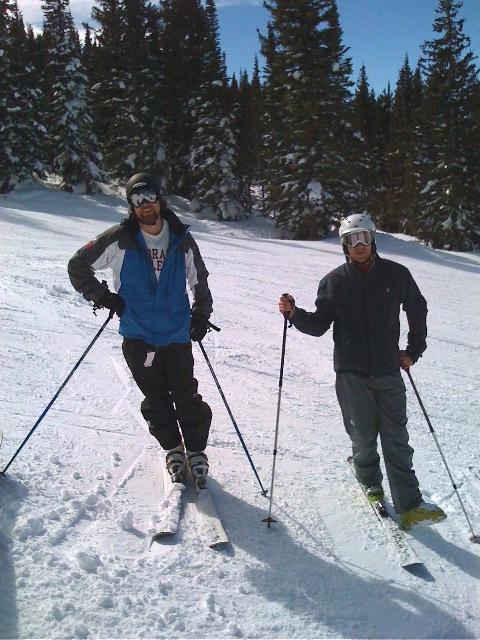How many poles can be seen?
Give a very brief answer. 4. How many people are visible?
Give a very brief answer. 2. How many tents in this image are to the left of the rainbow-colored umbrella at the end of the wooden walkway?
Give a very brief answer. 0. 